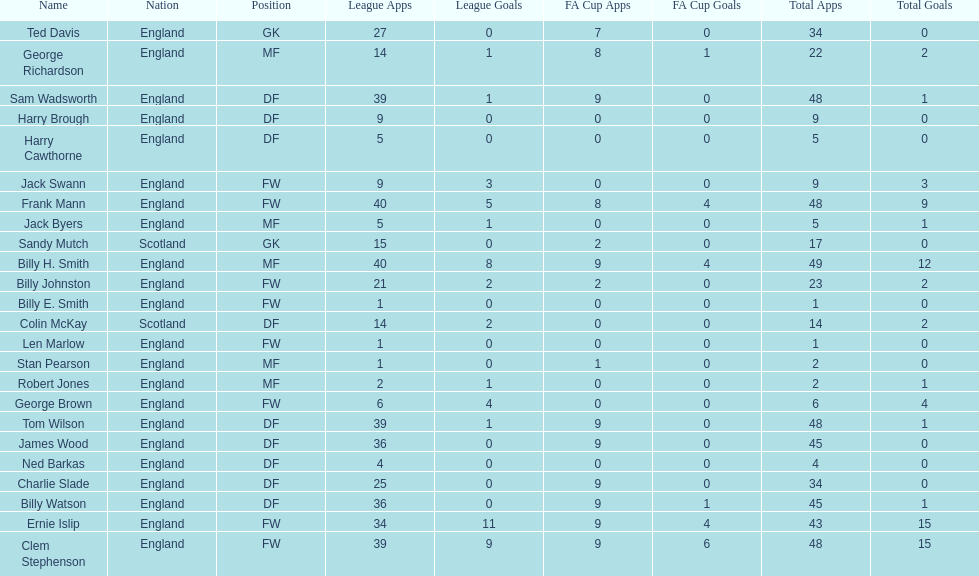What is the last name listed on this chart? James Wood. 